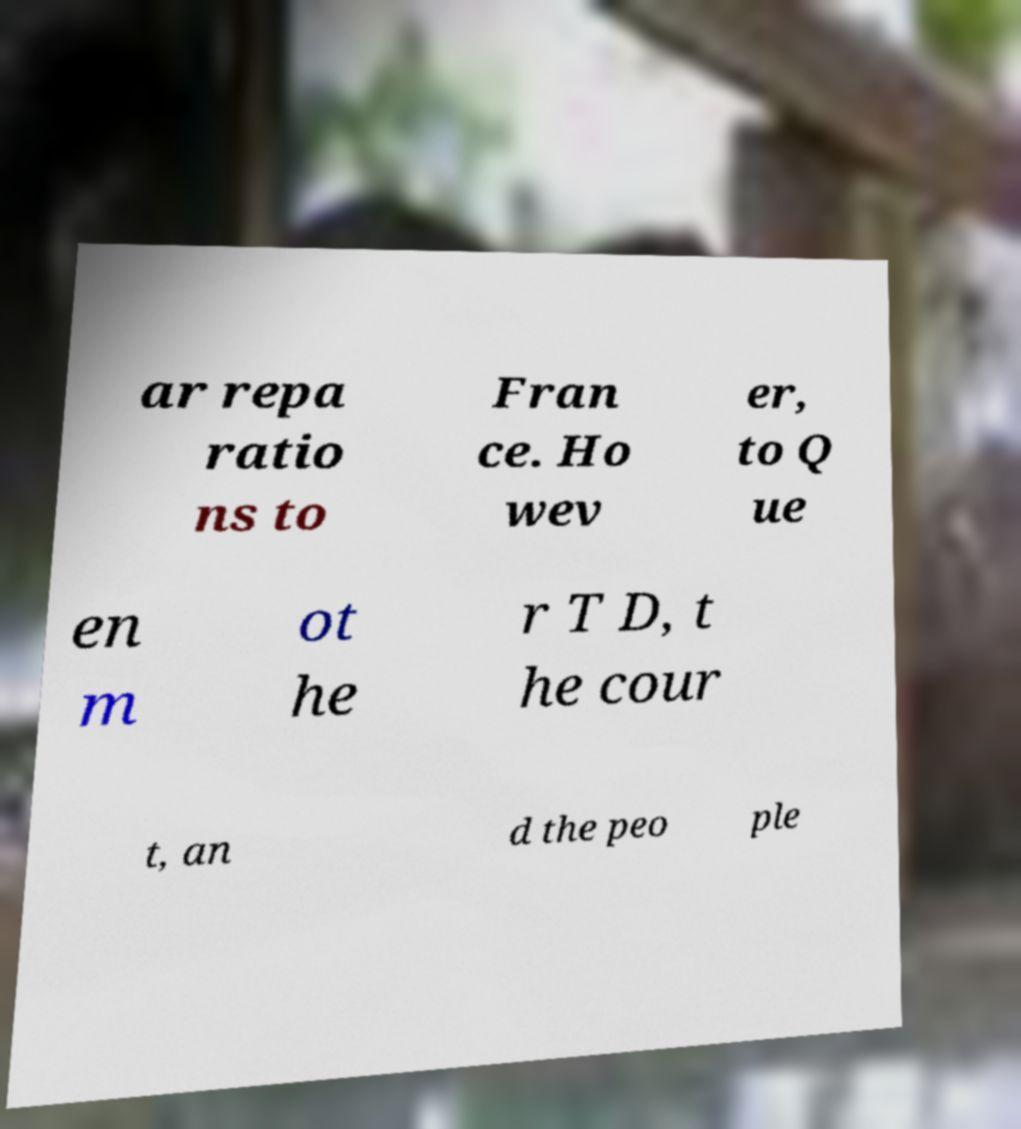Could you assist in decoding the text presented in this image and type it out clearly? ar repa ratio ns to Fran ce. Ho wev er, to Q ue en m ot he r T D, t he cour t, an d the peo ple 